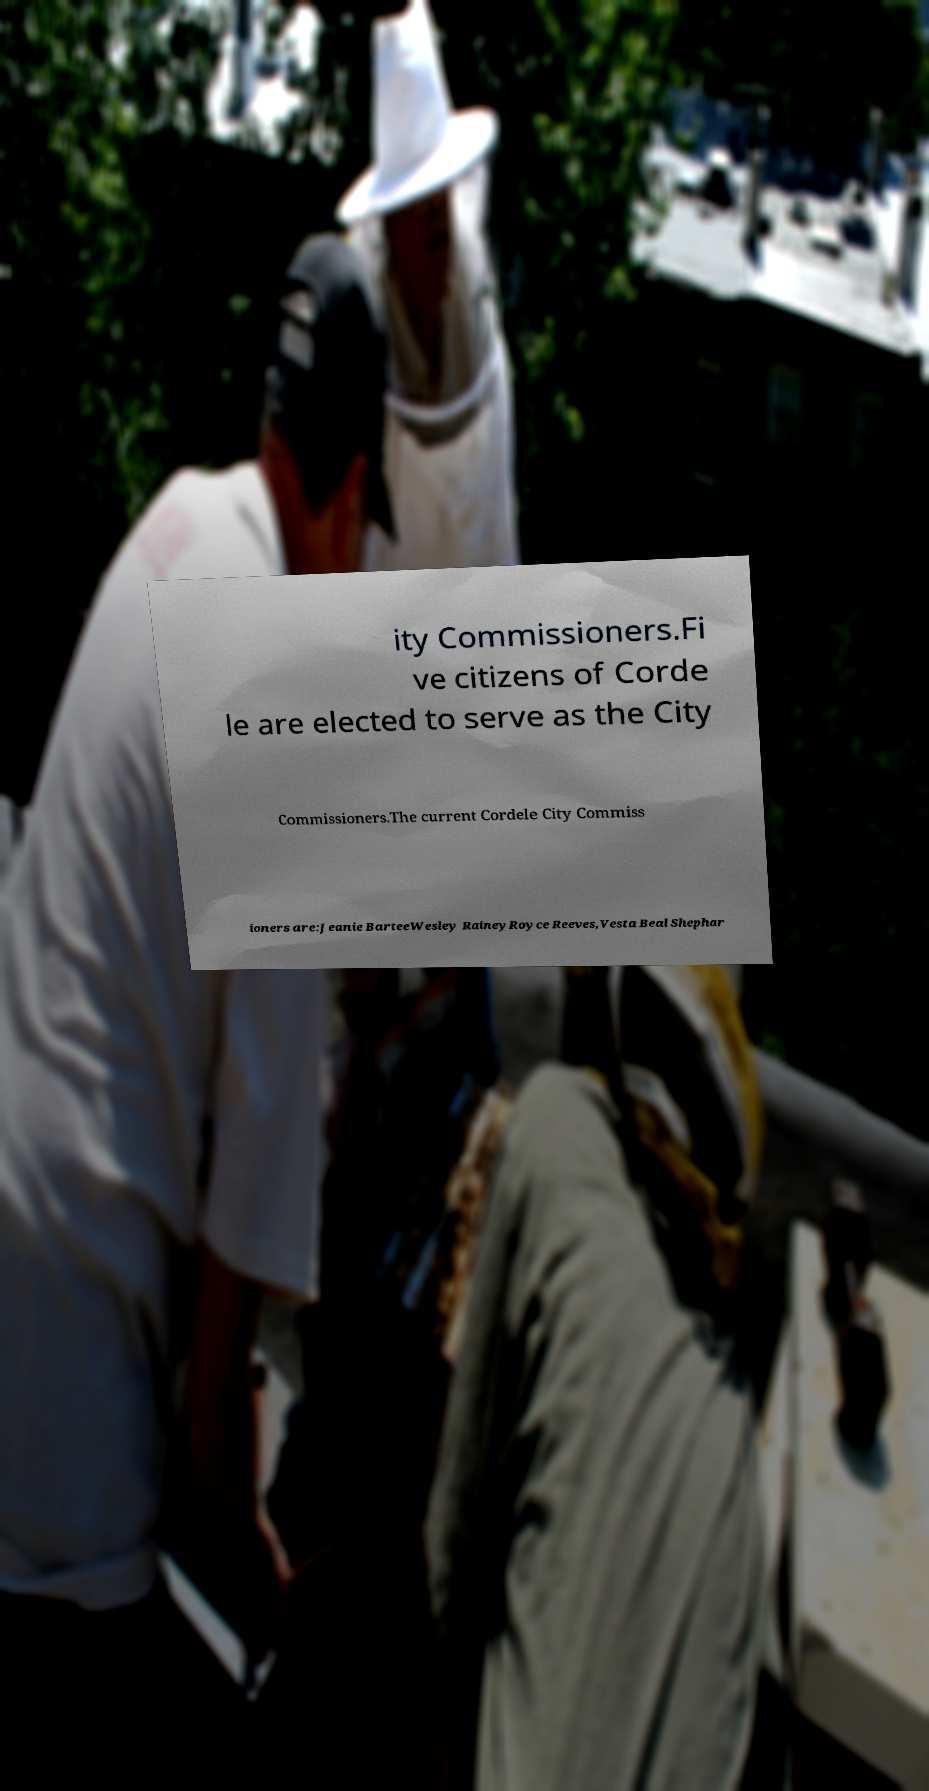There's text embedded in this image that I need extracted. Can you transcribe it verbatim? ity Commissioners.Fi ve citizens of Corde le are elected to serve as the City Commissioners.The current Cordele City Commiss ioners are:Jeanie BarteeWesley RaineyRoyce Reeves,Vesta Beal Shephar 